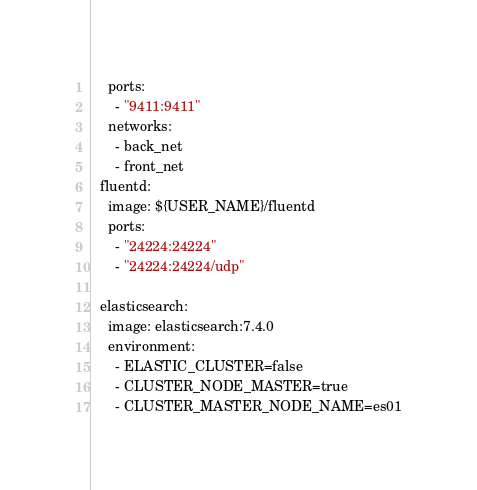Convert code to text. <code><loc_0><loc_0><loc_500><loc_500><_YAML_>    ports:
      - "9411:9411"
    networks:
      - back_net
      - front_net
  fluentd:
    image: ${USER_NAME}/fluentd
    ports:
      - "24224:24224"
      - "24224:24224/udp"

  elasticsearch:
    image: elasticsearch:7.4.0
    environment:
      - ELASTIC_CLUSTER=false
      - CLUSTER_NODE_MASTER=true
      - CLUSTER_MASTER_NODE_NAME=es01</code> 